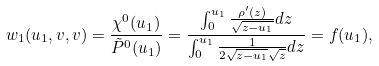<formula> <loc_0><loc_0><loc_500><loc_500>w _ { 1 } ( u _ { 1 } , v , v ) = \frac { \chi ^ { 0 } ( u _ { 1 } ) } { \tilde { P } ^ { 0 } ( u _ { 1 } ) } = \frac { \int _ { 0 } ^ { u _ { 1 } } \frac { \rho ^ { \prime } ( z ) } { \sqrt { z - u _ { 1 } } } d z } { \int _ { 0 } ^ { u _ { 1 } } \frac { 1 } { 2 \sqrt { z - u _ { 1 } } \sqrt { z } } d z } = f ( u _ { 1 } ) ,</formula> 